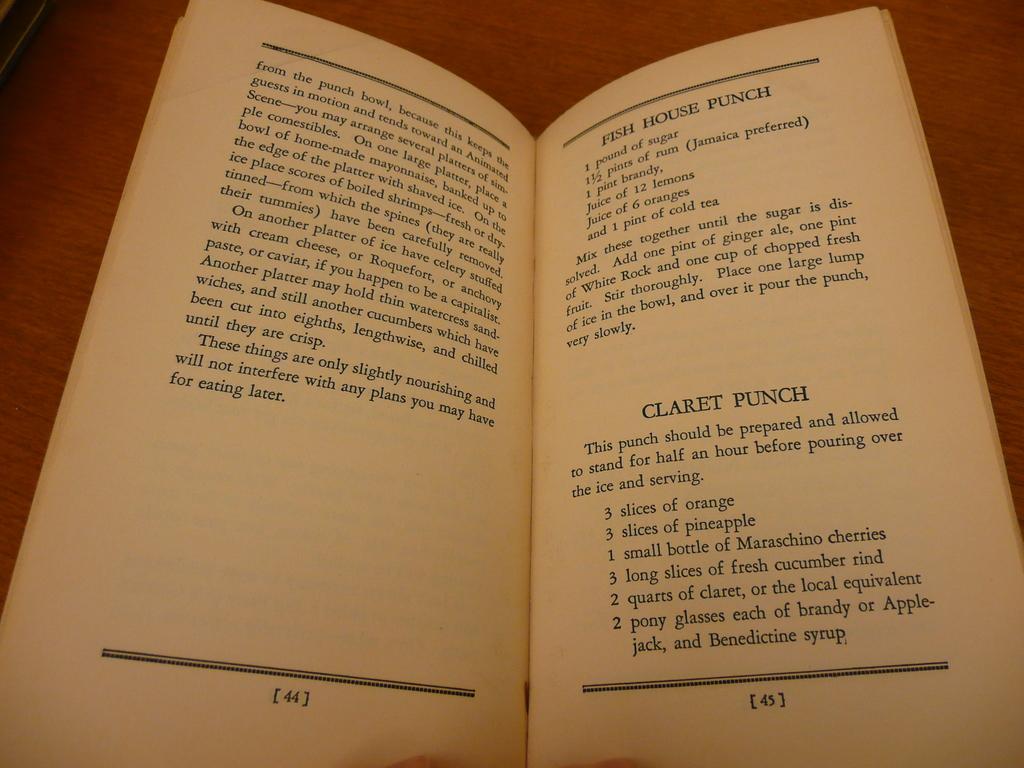What is the page number on the right?
Your answer should be very brief. 45. 